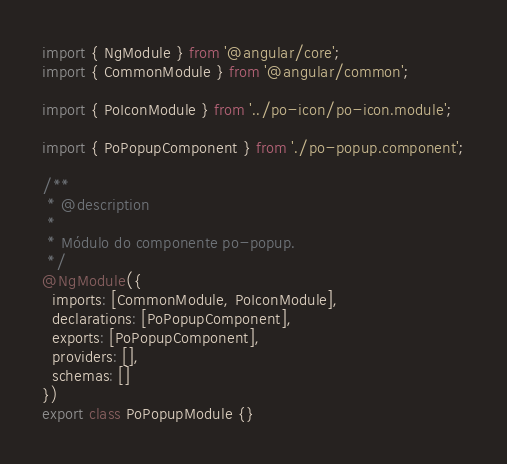<code> <loc_0><loc_0><loc_500><loc_500><_TypeScript_>import { NgModule } from '@angular/core';
import { CommonModule } from '@angular/common';

import { PoIconModule } from '../po-icon/po-icon.module';

import { PoPopupComponent } from './po-popup.component';

/**
 * @description
 *
 * Módulo do componente po-popup.
 */
@NgModule({
  imports: [CommonModule, PoIconModule],
  declarations: [PoPopupComponent],
  exports: [PoPopupComponent],
  providers: [],
  schemas: []
})
export class PoPopupModule {}
</code> 